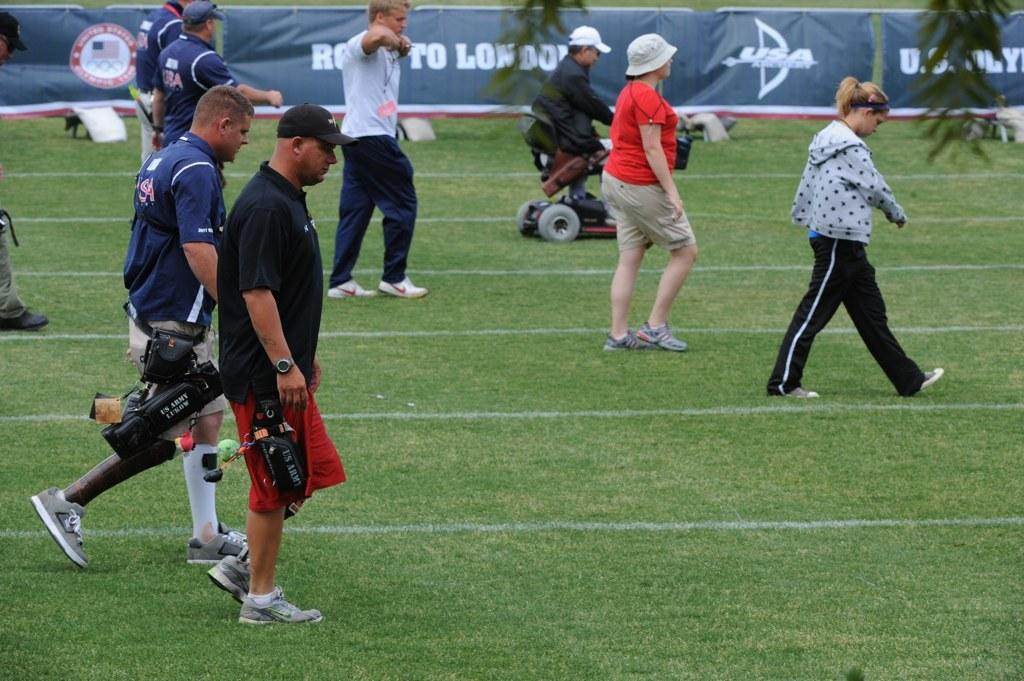<image>
Relay a brief, clear account of the picture shown. A blue banner with words starting with R and L hangs behind people walking on a field. 